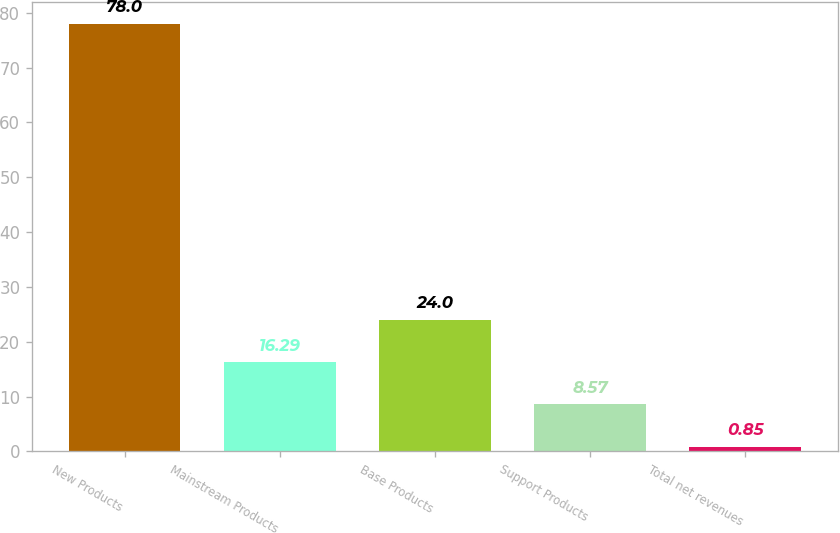Convert chart. <chart><loc_0><loc_0><loc_500><loc_500><bar_chart><fcel>New Products<fcel>Mainstream Products<fcel>Base Products<fcel>Support Products<fcel>Total net revenues<nl><fcel>78<fcel>16.29<fcel>24<fcel>8.57<fcel>0.85<nl></chart> 